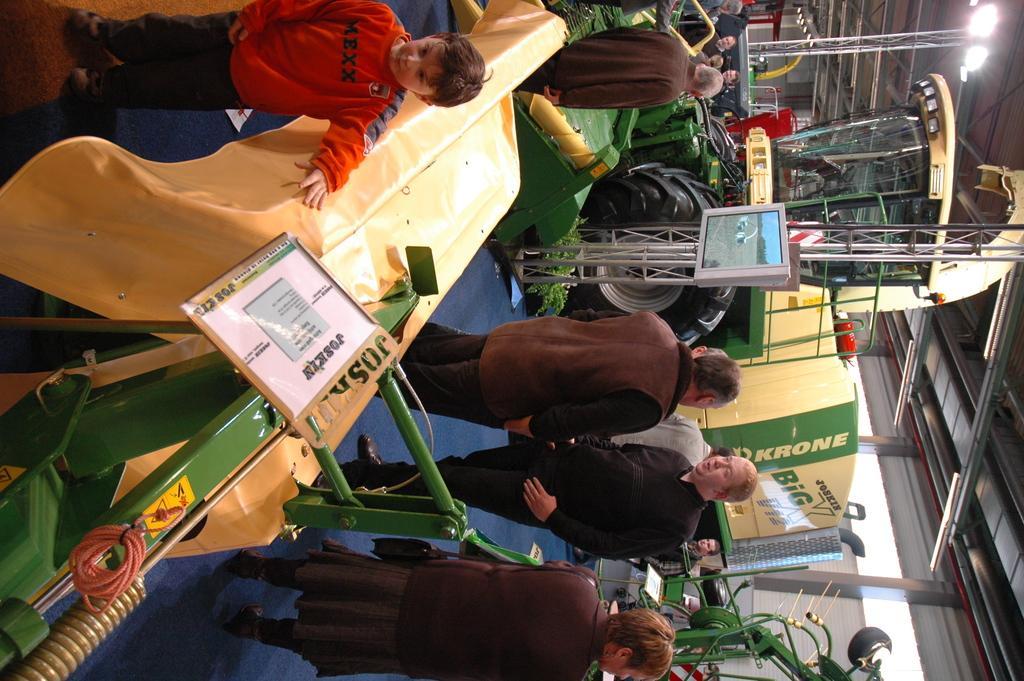In one or two sentences, can you explain what this image depicts? On the left there is a kid standing near a machine. In the center of the picture there are people, tractor, television and other objects. On the right there are lights, machinery and other objects. In the center of the background there are lights and other objects. 